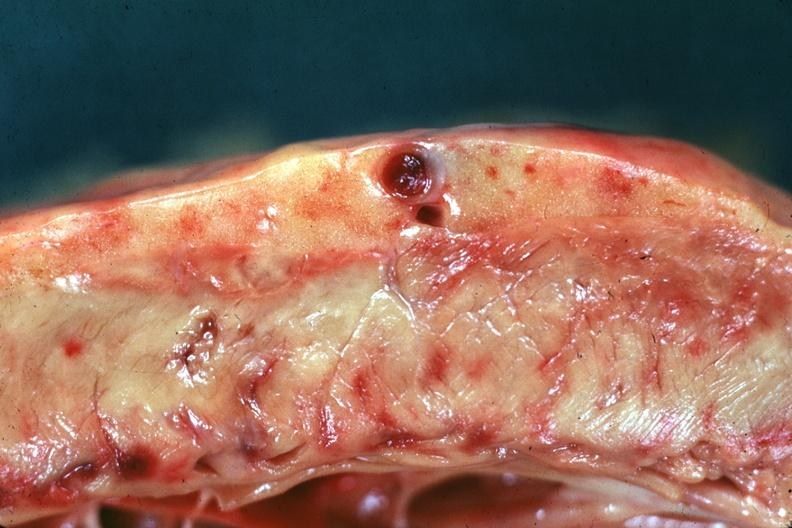what is present?
Answer the question using a single word or phrase. Calculi 